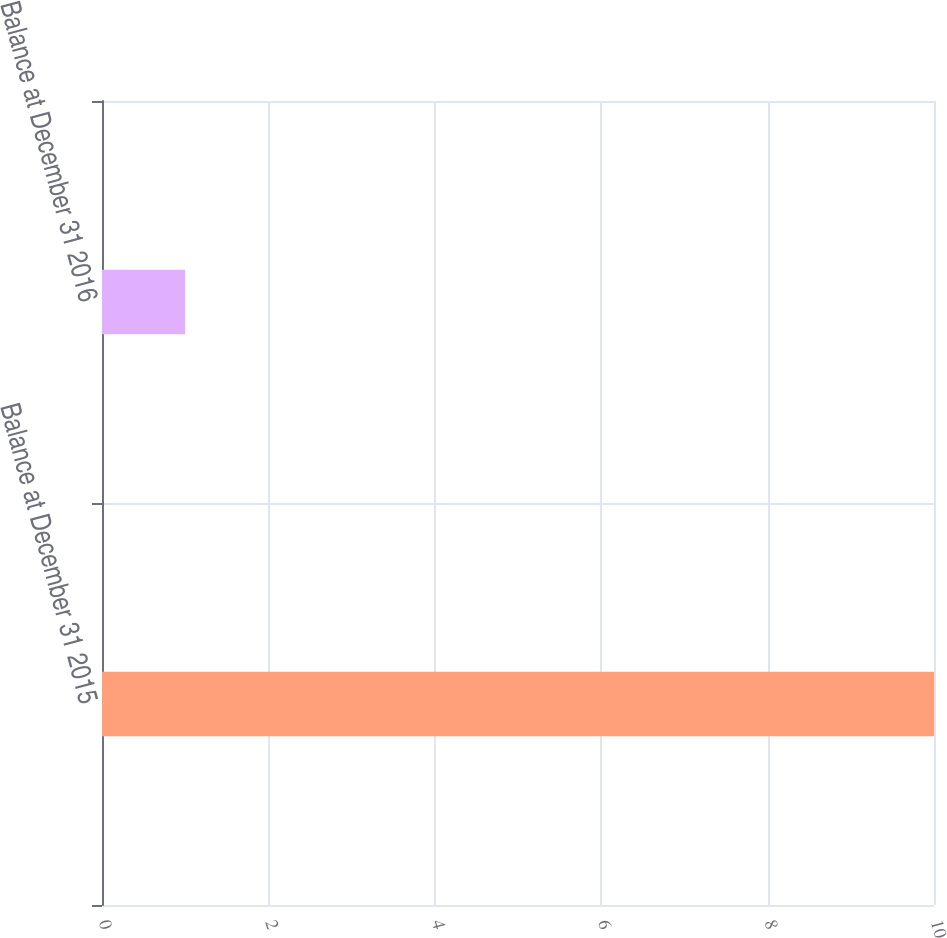<chart> <loc_0><loc_0><loc_500><loc_500><bar_chart><fcel>Balance at December 31 2015<fcel>Balance at December 31 2016<nl><fcel>10<fcel>1<nl></chart> 